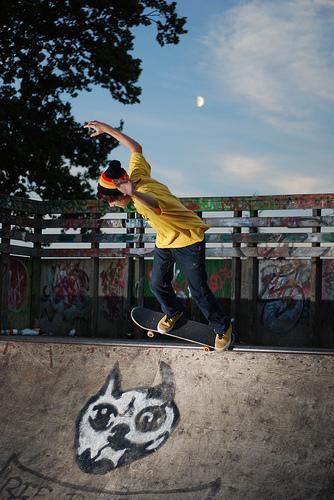How many boys are there?
Give a very brief answer. 1. 